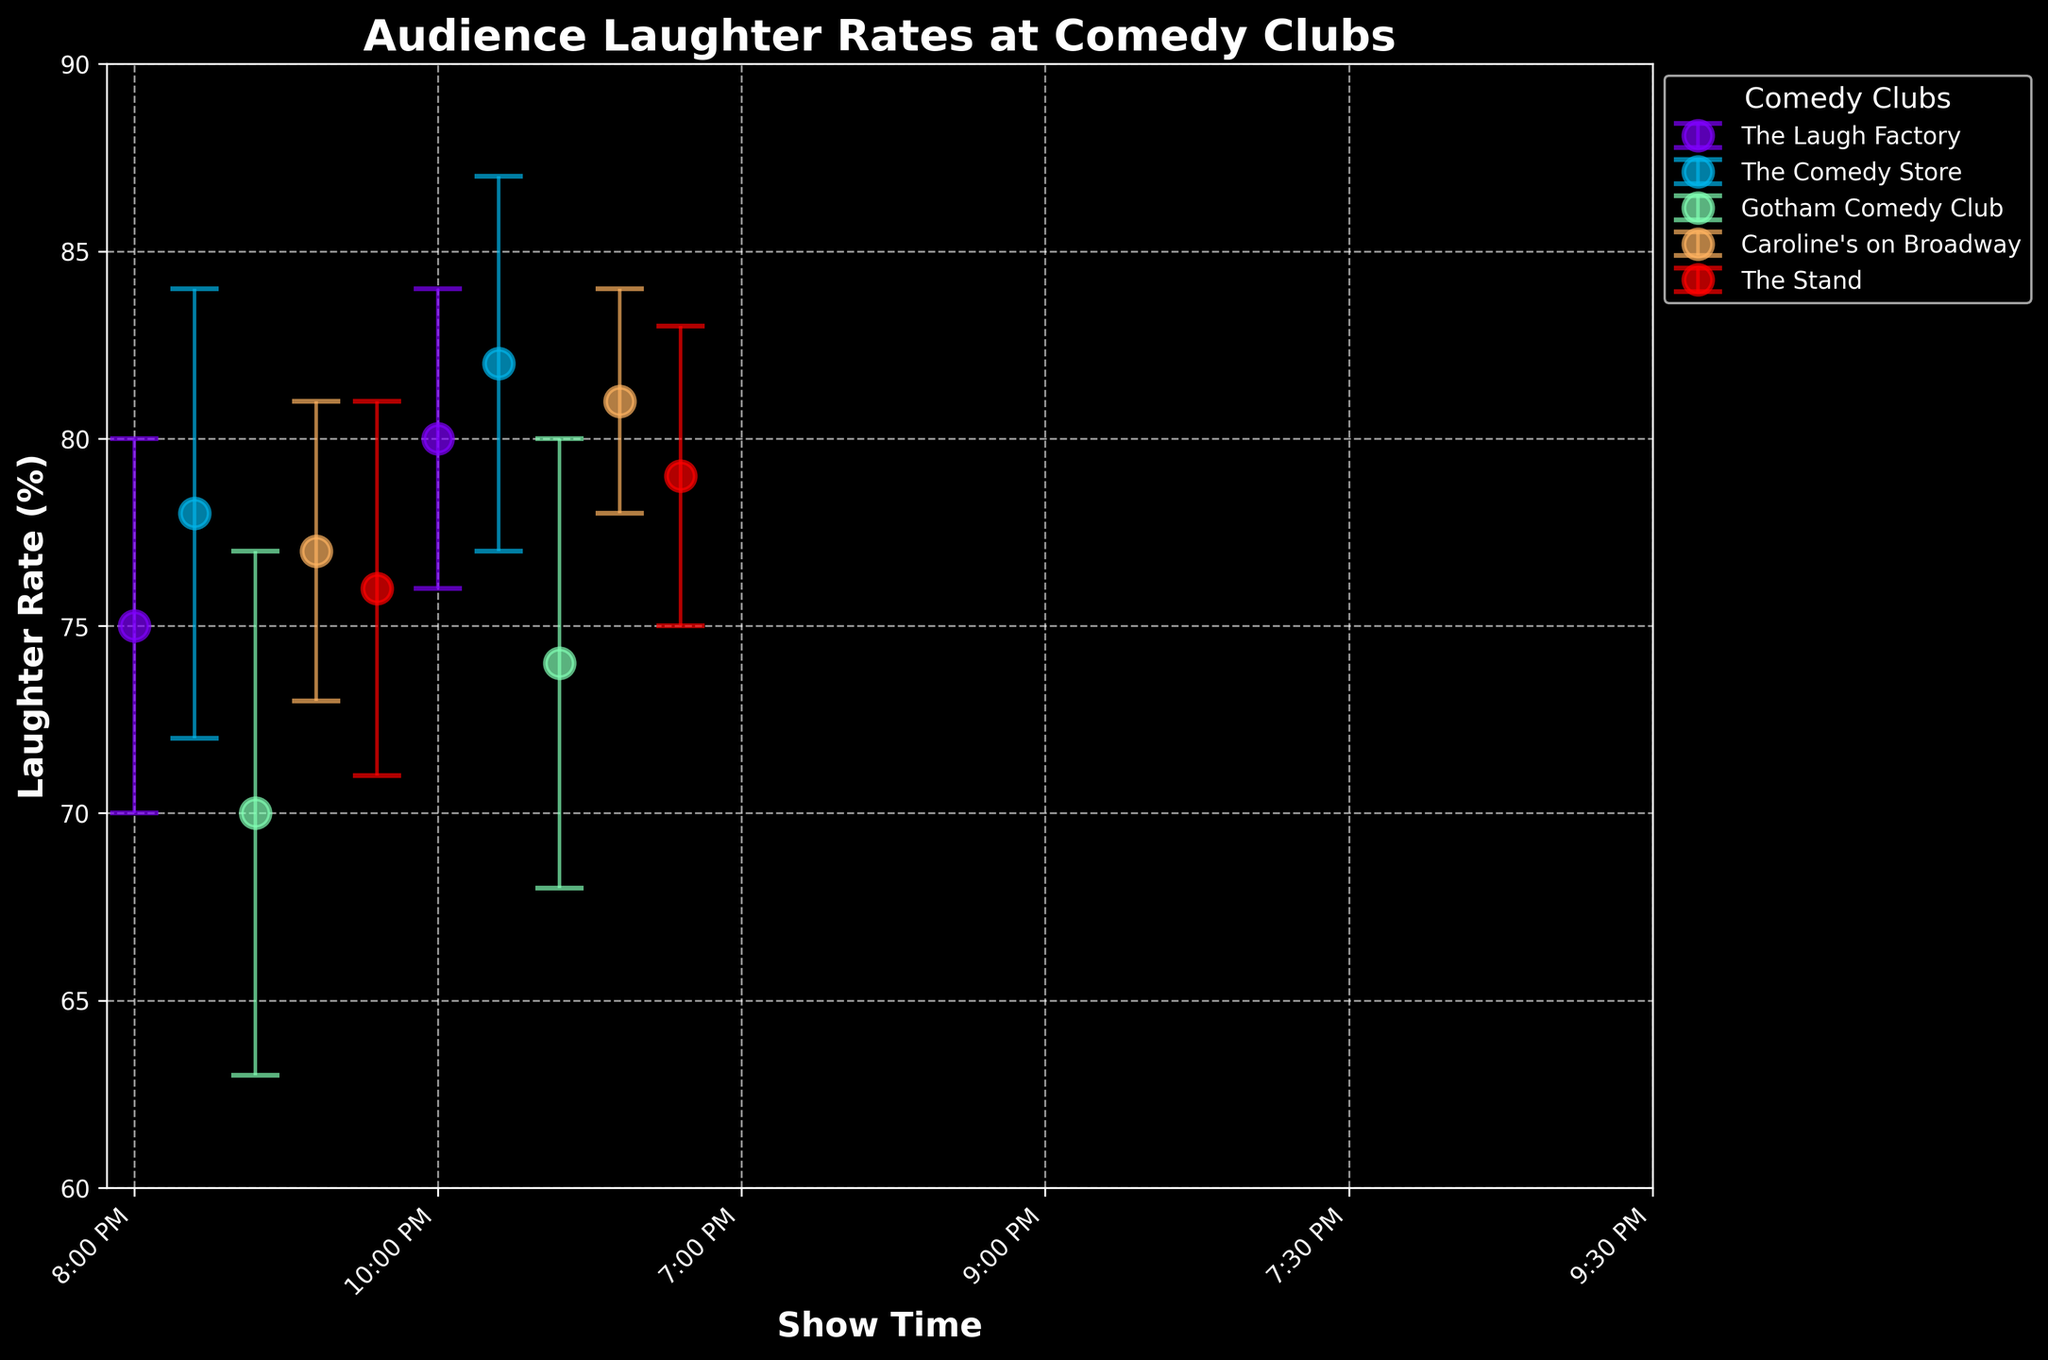Which comedy club has the highest average laughter rate? To determine which comedy club has the highest average laughter rate, look at the laughter rates for each showtime per club. Calculate the average for each club and compare them. The Club with the highest average laughter rate is The Comedy Store with an average laughter rate of (78+82)/2 = 80%.
Answer: The Comedy Store What is the title of the figure? The title of a figure is usually displayed at the top. In this case, the title is "Audience Laughter Rates at Comedy Clubs".
Answer: Audience Laughter Rates at Comedy Clubs Which showtime at The Stand has a higher laughter rate? To find out which showtime has a higher laughter rate, compare the laughter rates at 8:00 PM and 10:00 PM for The Stand. The laughter rates are 76% and 79% respectively. 10:00 PM has a higher laughter rate.
Answer: 10:00 PM Which comedy club has the smallest error bars? The length of the error bars indicates the level of variability. Smaller error bars signify less variability. Caroline's on Broadway has the smallest error bars with errors of 4% and 3% for its showtimes.
Answer: Caroline's on Broadway What is the laughter rate range for Gotham Comedy Club? The laughter rate range can be found by looking at the highest and lowest laughter rates for Gotham Comedy Club. The highest laughter rate is 74% and the lowest is 70%. The range is 74% - 70% = 4%.
Answer: 4% Which comedy club has the largest difference in laughter rates between its showtimes? To find this, calculate the difference in laughter rates between the showtimes for each club and compare them. Gotham Comedy Club has the largest difference with a difference of 74% - 70% = 4%.
Answer: Gotham Comedy Club What's the average laughter rate at Caroline's on Broadway for both showtimes? To calculate the average laughter rate at Caroline's on Broadway, add the laughter rates for both showtimes and divide by 2. The rates are 77% and 81%. The average is (77+81)/2 = 79%.
Answer: 79% How many showtimes are displayed in total for all comedy clubs? Count the number of unique showtimes displayed across all comedy clubs. There are 10 showtimes in total.
Answer: 10 Which comedy club's 9:30 PM showtime has the highest laughter rate? Look at the laughter rates for the 9:30 PM showtime across all comedy clubs. Caroline's on Broadway at 9:30 PM has the highest laughter rate of 81%.
Answer: Caroline's on Broadway What is the laughter rate for The Laugh Factory at 8:00 PM, and how does it compare to the same club’s 10:00 PM showtime? The laughter rate for The Laugh Factory at 8:00 PM is 75%, while the rate at 10:00 PM is 80%. The 10:00 PM showtime has a higher laughter rate by 5%.
Answer: 10:00 PM is higher by 5% 